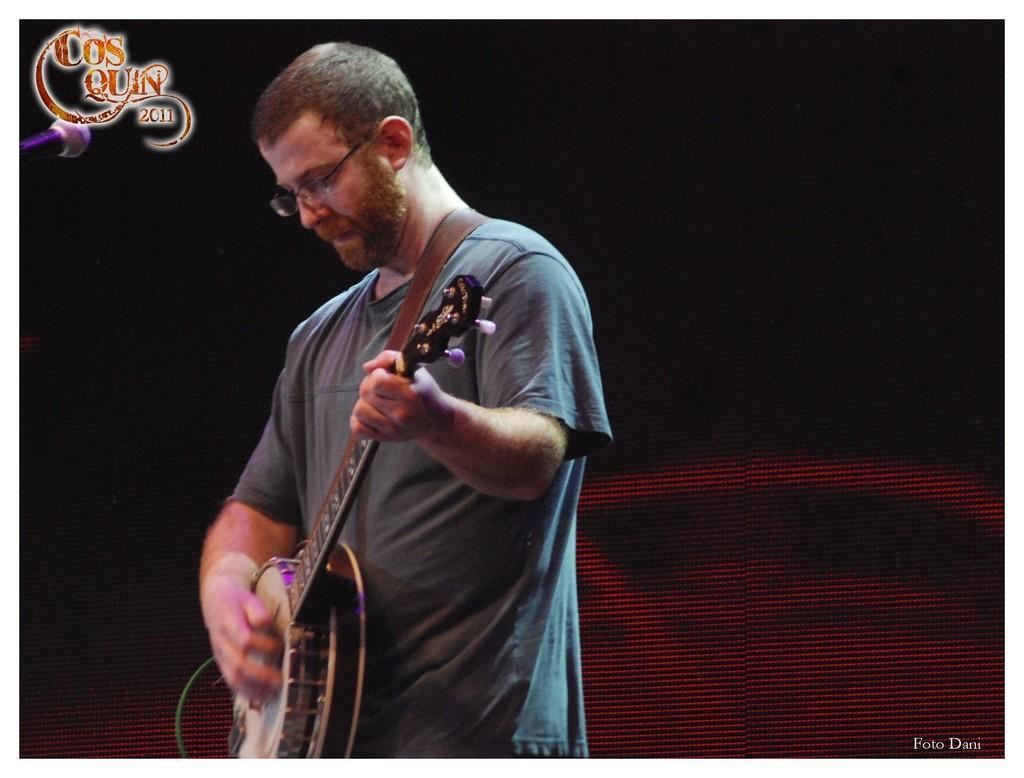Please provide a concise description of this image. In this picture I can see there is a man standing here and he is playing a guitar and in the backdrop there is a screen. 